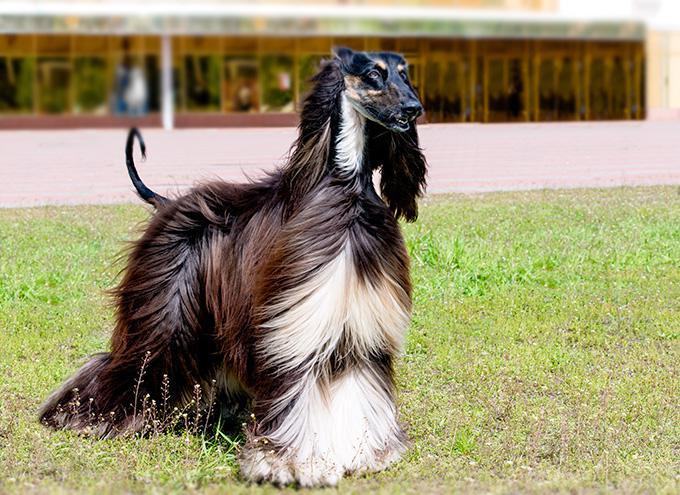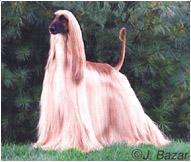The first image is the image on the left, the second image is the image on the right. Evaluate the accuracy of this statement regarding the images: "At least one dog has black fur.". Is it true? Answer yes or no. Yes. The first image is the image on the left, the second image is the image on the right. For the images displayed, is the sentence "there is one dog lying down in the image on the left" factually correct? Answer yes or no. No. 